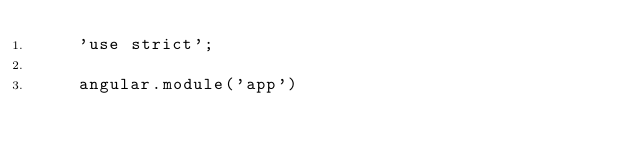Convert code to text. <code><loc_0><loc_0><loc_500><loc_500><_JavaScript_>    'use strict';

    angular.module('app')
</code> 